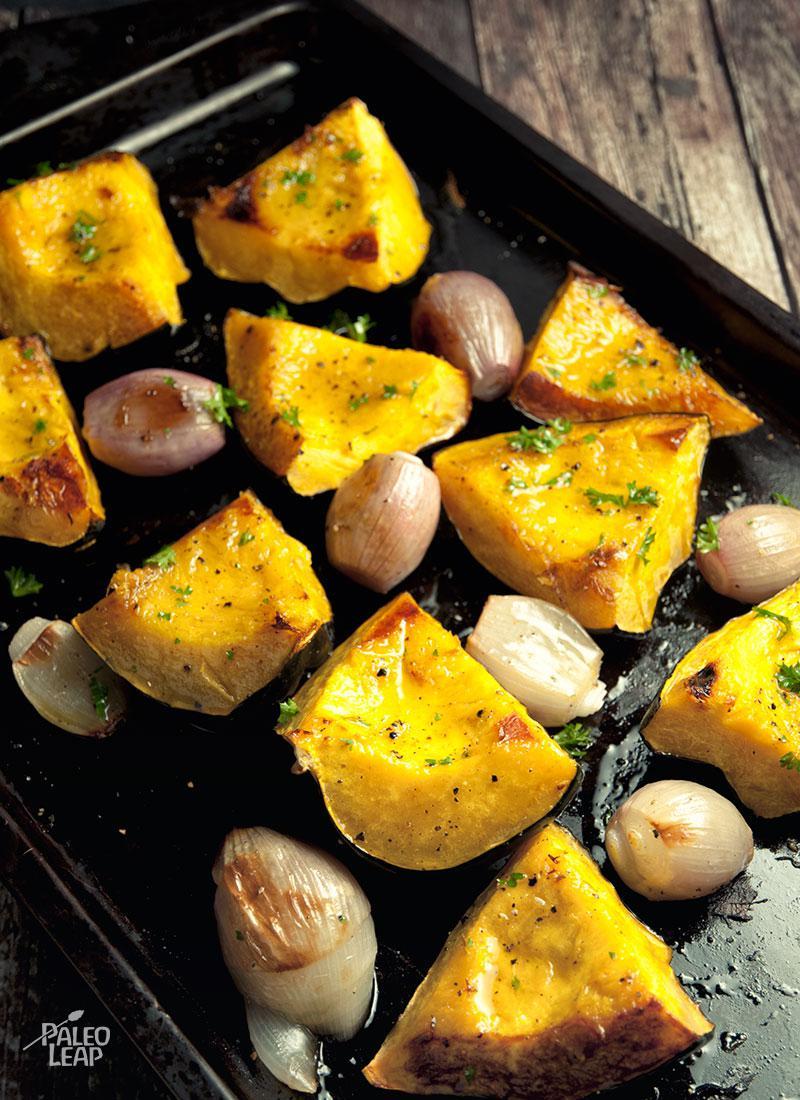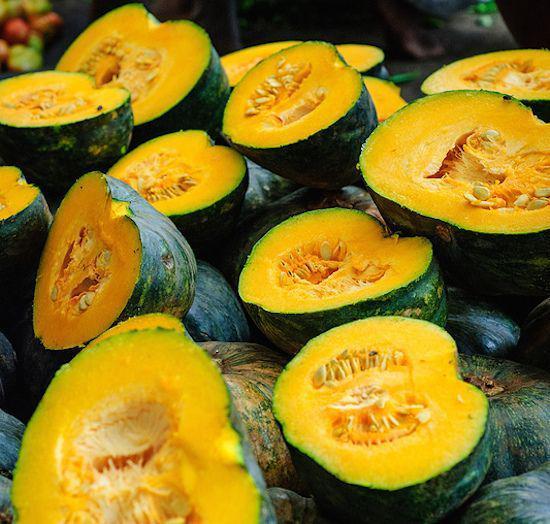The first image is the image on the left, the second image is the image on the right. For the images shown, is this caption "The left image contains squash cut in half." true? Answer yes or no. No. 